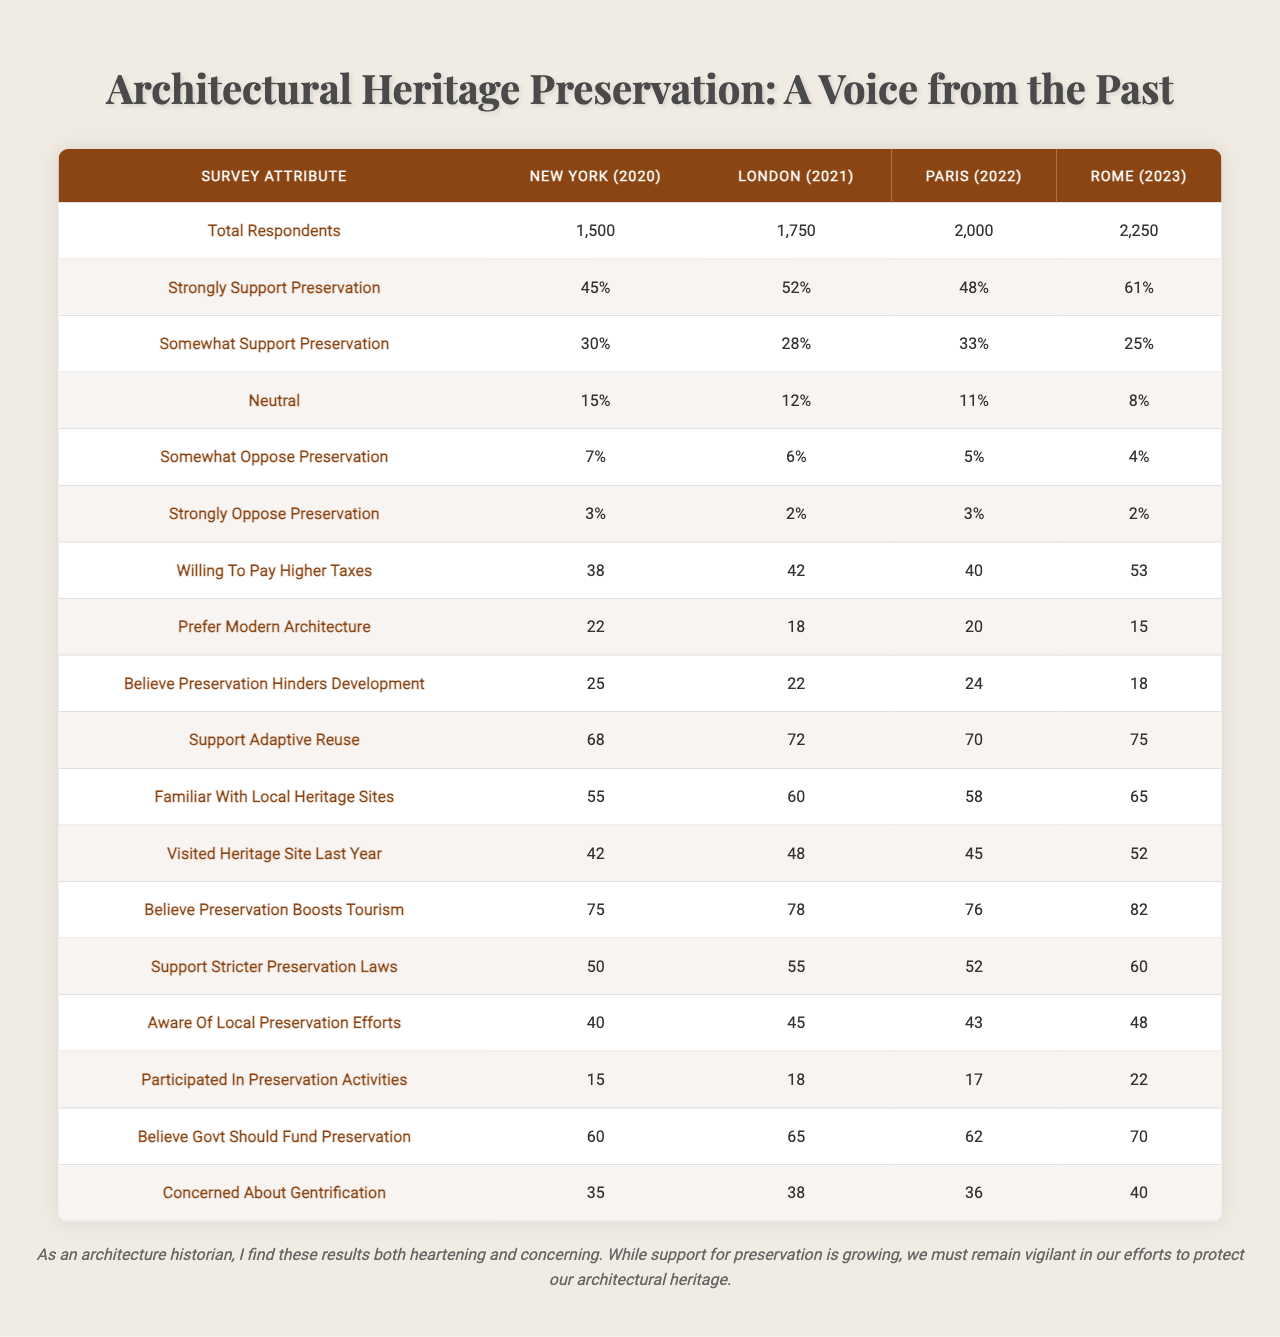What percentage of respondents in Rome (2023) support preservation strongly? According to the table, 61% of respondents in Rome (2023) indicated they strongly support preservation.
Answer: 61% What was the total number of respondents in Paris (2022)? The table shows that there were 2,000 respondents in Paris (2022).
Answer: 2,000 How does the percentage of people who support stricter preservation laws in London (2021) compare to those who do not? In London (2021), 55% support stricter preservation laws, while the opposition comprises 8% (3% strongly oppose + 5% somewhat oppose). Thus, more people support the laws than oppose them.
Answer: Yes Which city had the highest percentage of respondents willing to pay higher taxes for preservation, and what was that percentage? The table reveals that Rome (2023) had the highest percentage at 53% of respondents willing to pay higher taxes for preservation.
Answer: Rome, 53% What is the difference in the percentage of respondents who believe preservation boosts tourism between New York (2020) and Rome (2023)? In New York (2020), 75% believe preservation boosts tourism, while in Rome (2023) it is 82%. The difference is 82% - 75% = 7%.
Answer: 7% What is the average percentage of respondents across all cities who support adaptive reuse? The averages are: New York (2020) 68%, London (2021) 72%, Paris (2022) 70%, Rome (2023) 75%. The sum is 68 + 72 + 70 + 75 = 285, and dividing by 4 gives an average of 285 / 4 = 71.25%.
Answer: 71.25% Is the percentage of respondents in Paris (2022) who visited a heritage site last year higher than the percentage in New York (2020)? The table shows that in Paris (2022), 45% visited a heritage site last year, while in New York (2020), 42% did. Therefore, the percentage in Paris is higher.
Answer: Yes What percentage of total respondents in 2021 supported preserving architecture? To find the supportive percentage in London (2021), sum the strongly and somewhat support categories, which are 52% + 28% = 80%.
Answer: 80% How many more respondents in Rome (2023) believe that preservation hinders development compared to New York (2020)? In Rome (2023), 18% believe preservation hinders development, while in New York (2020), it is 25%. The difference is 25% - 18% = 7%.
Answer: 7% Which city had the lowest percentage of respondents who participated in preservation activities, and what was that percentage? The table indicates that New York (2020) had the lowest percentage of respondents participating in preservation activities at 15%.
Answer: New York, 15% How many people in total across all cities believe the government should fund preservation? The sums for each city are: New York (2020) 60%, London (2021) 65%, Paris (2022) 62%, and Rome (2023) 70%. Combining these gives 60 + 65 + 62 + 70 = 257%. Since these are percentages, we maintain the percentage rather than convert to a number of people, so it remains 257%.
Answer: 257% 